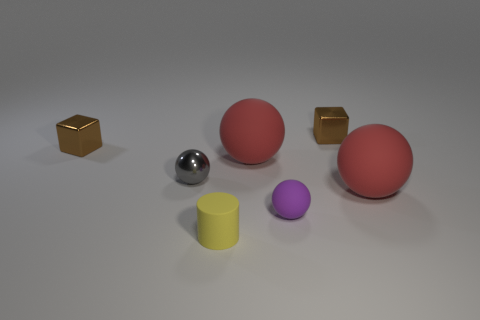What is the color of the tiny rubber object that is behind the matte cylinder?
Your answer should be compact. Purple. Is there a ball of the same size as the rubber cylinder?
Your answer should be very brief. Yes. There is a gray thing that is the same size as the purple sphere; what is it made of?
Make the answer very short. Metal. What number of objects are shiny things to the right of the yellow rubber object or brown blocks that are left of the tiny gray metal thing?
Offer a terse response. 2. Are there any large red matte objects that have the same shape as the small gray metallic thing?
Offer a very short reply. Yes. How many matte objects are either big green things or red objects?
Offer a terse response. 2. There is a gray thing; what shape is it?
Your answer should be very brief. Sphere. What number of tiny balls are the same material as the yellow cylinder?
Make the answer very short. 1. The small thing that is the same material as the yellow cylinder is what color?
Your response must be concise. Purple. Is the size of the brown shiny cube to the left of the purple thing the same as the yellow cylinder?
Your answer should be very brief. Yes. 